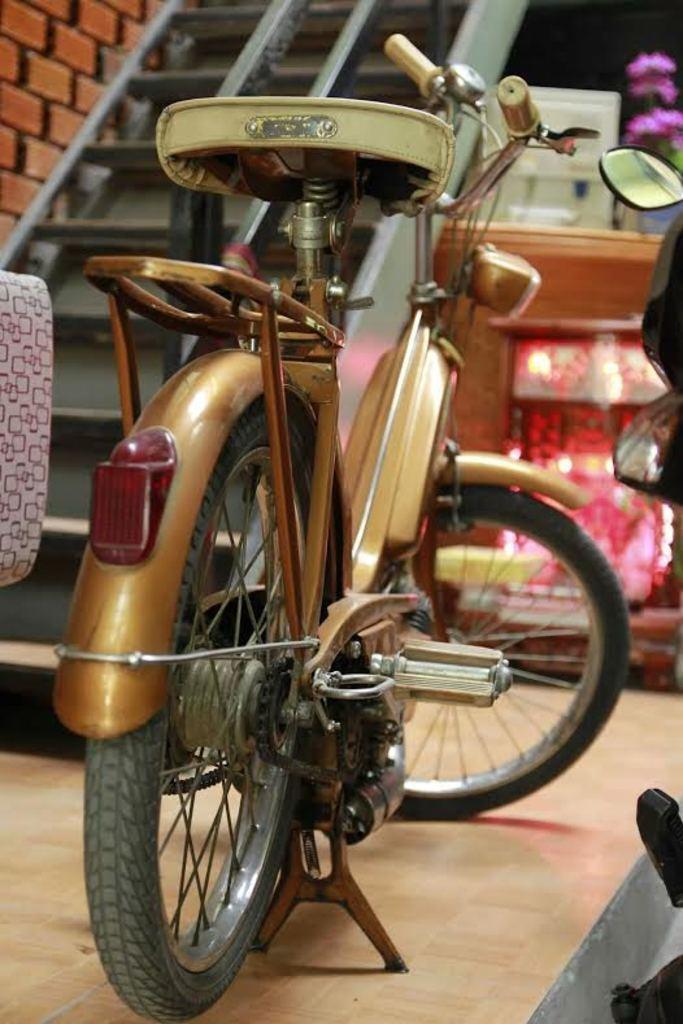Please provide a concise description of this image. In this picture we can see a bicycle on the path and in front of the bicycle there is a staircase, mirror and other things. 